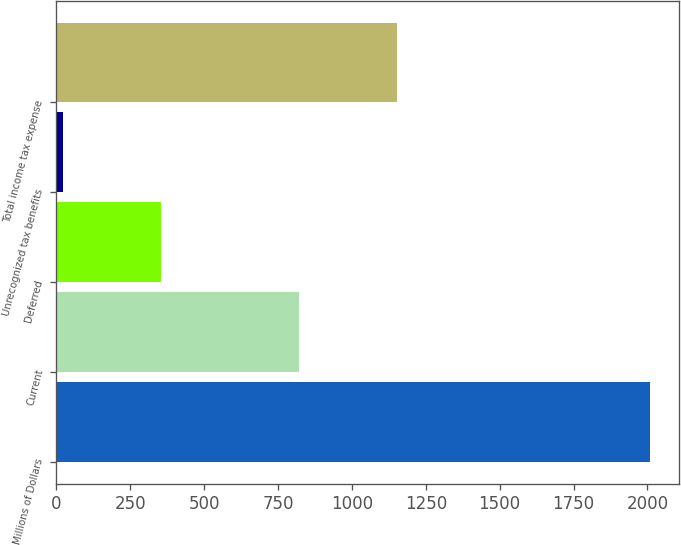Convert chart. <chart><loc_0><loc_0><loc_500><loc_500><bar_chart><fcel>Millions of Dollars<fcel>Current<fcel>Deferred<fcel>Unrecognized tax benefits<fcel>Total income tax expense<nl><fcel>2007<fcel>822<fcel>354<fcel>22<fcel>1154<nl></chart> 